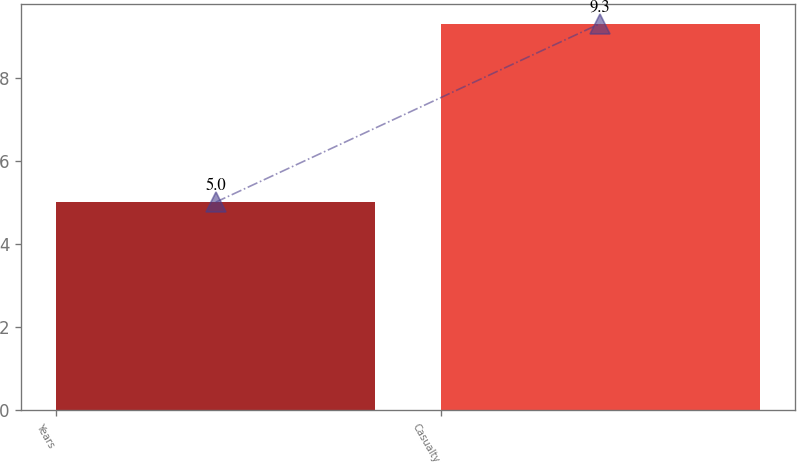<chart> <loc_0><loc_0><loc_500><loc_500><bar_chart><fcel>Years<fcel>Casualty<nl><fcel>5<fcel>9.3<nl></chart> 